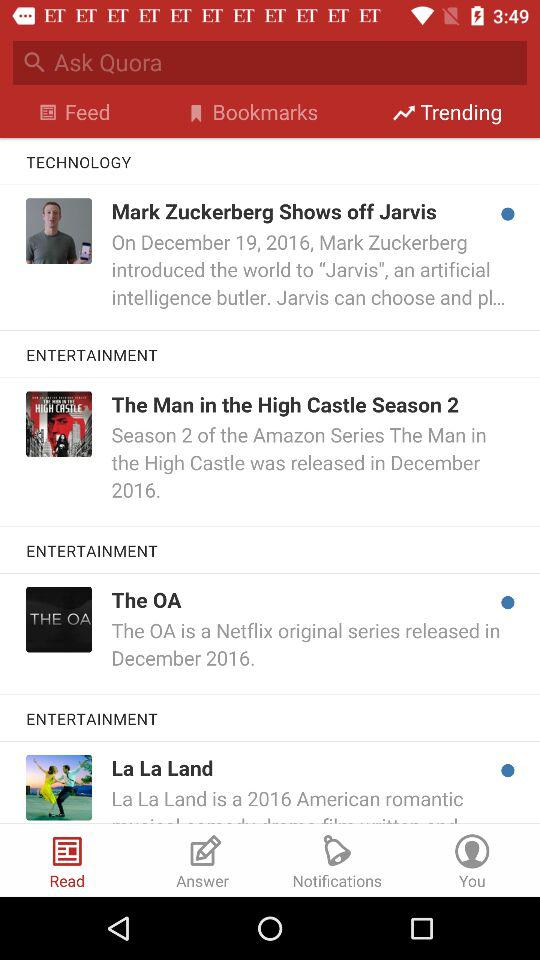How many items in the Entertainment section were released in December 2016?
Answer the question using a single word or phrase. 3 